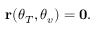<formula> <loc_0><loc_0><loc_500><loc_500>\begin{array} { r } { { r } ( \theta _ { T } , \theta _ { v } ) = { 0 } . } \end{array}</formula> 